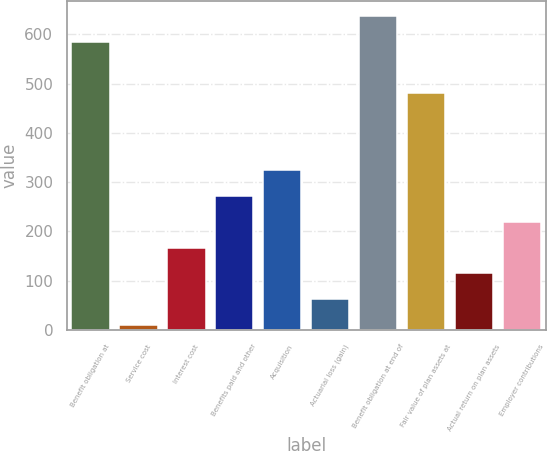Convert chart. <chart><loc_0><loc_0><loc_500><loc_500><bar_chart><fcel>Benefit obligation at<fcel>Service cost<fcel>Interest cost<fcel>Benefits paid and other<fcel>Acquisition<fcel>Actuarial loss (gain)<fcel>Benefit obligation at end of<fcel>Fair value of plan assets at<fcel>Actual return on plan assets<fcel>Employer contributions<nl><fcel>584.44<fcel>10.9<fcel>167.32<fcel>271.6<fcel>323.74<fcel>63.04<fcel>636.58<fcel>480.16<fcel>115.18<fcel>219.46<nl></chart> 